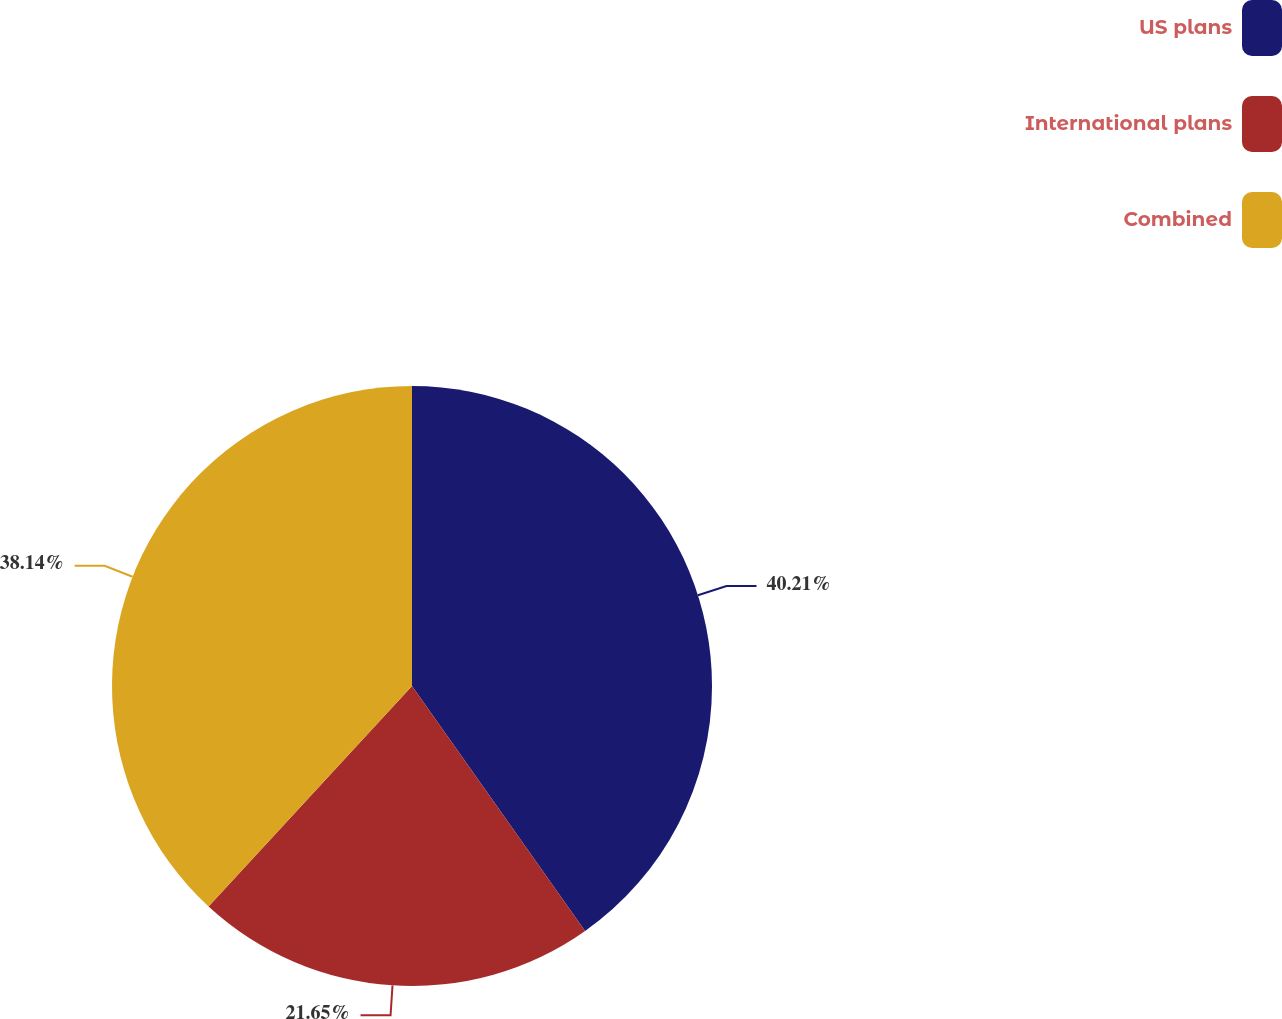<chart> <loc_0><loc_0><loc_500><loc_500><pie_chart><fcel>US plans<fcel>International plans<fcel>Combined<nl><fcel>40.21%<fcel>21.65%<fcel>38.14%<nl></chart> 